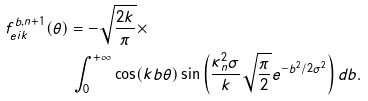Convert formula to latex. <formula><loc_0><loc_0><loc_500><loc_500>f ^ { b , n + 1 } _ { e i k } ( \theta ) & = - \sqrt { \frac { 2 k } { \pi } } \times \\ & \, \int _ { 0 } ^ { + \infty } \cos ( k b \theta ) \sin \left ( \frac { \kappa ^ { 2 } _ { n } \sigma } { k } \sqrt { \frac { \pi } { 2 } } e ^ { - b ^ { 2 } / 2 \sigma ^ { 2 } } \right ) d b .</formula> 